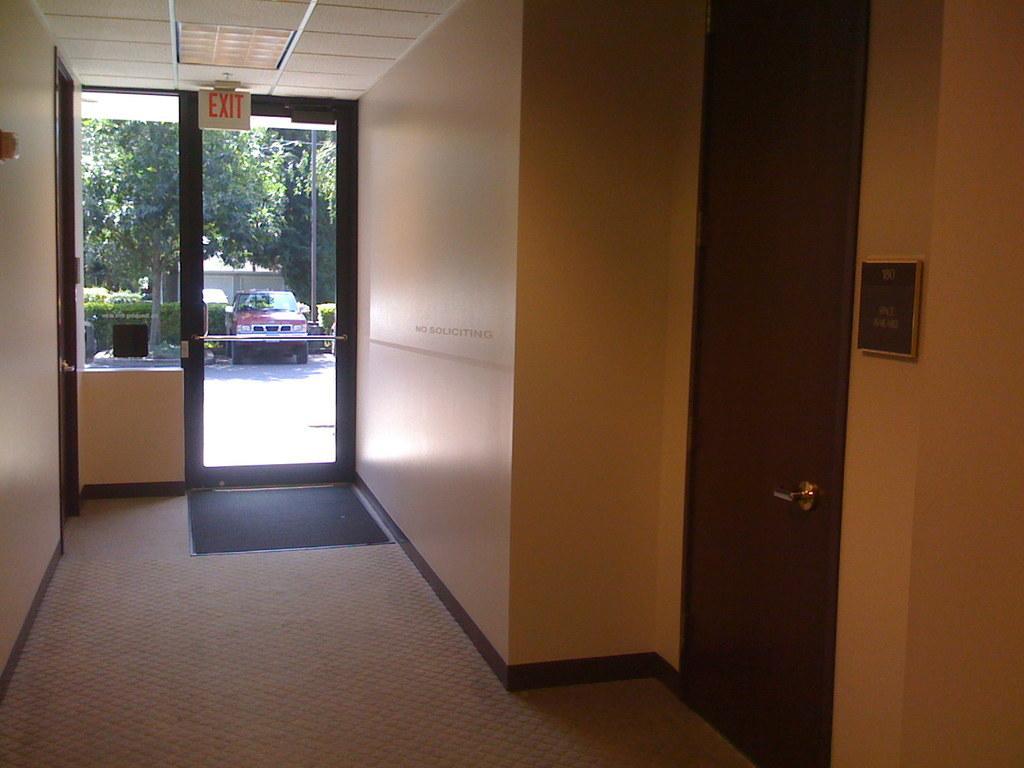How would you summarize this image in a sentence or two? In this image there is an inside view of a building, there are doors, there is a wall, there are objects on the wall, there is a car, there are trees, there is a roof towards the top of the image, there are lights, there is a board, there is text on the board, there is floor towards the bottom of the image, there is an object on the floor, there is a pole, there are plants. 